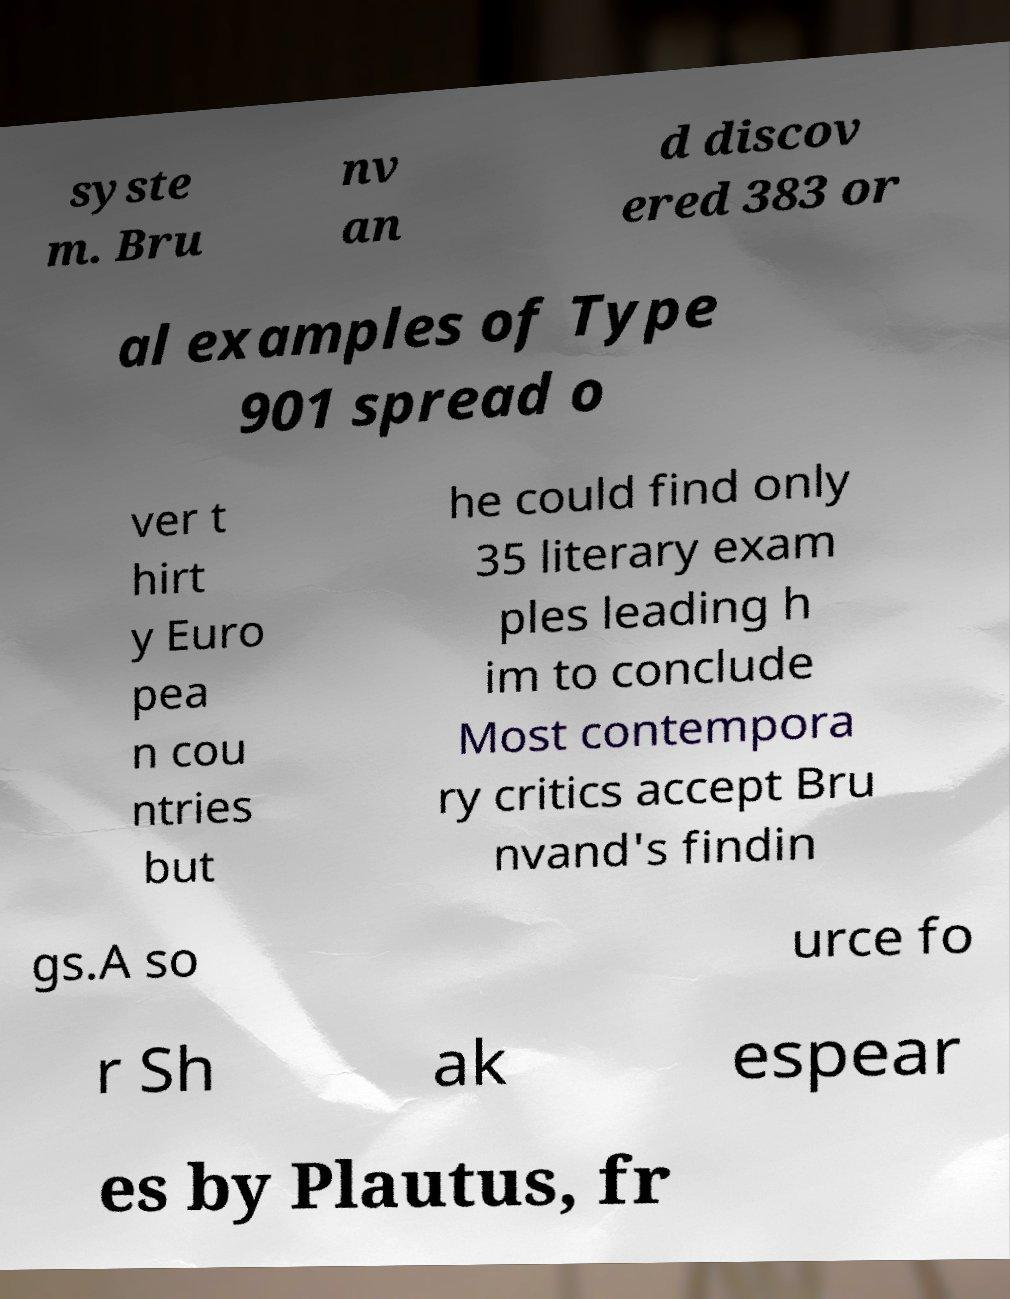For documentation purposes, I need the text within this image transcribed. Could you provide that? syste m. Bru nv an d discov ered 383 or al examples of Type 901 spread o ver t hirt y Euro pea n cou ntries but he could find only 35 literary exam ples leading h im to conclude Most contempora ry critics accept Bru nvand's findin gs.A so urce fo r Sh ak espear es by Plautus, fr 